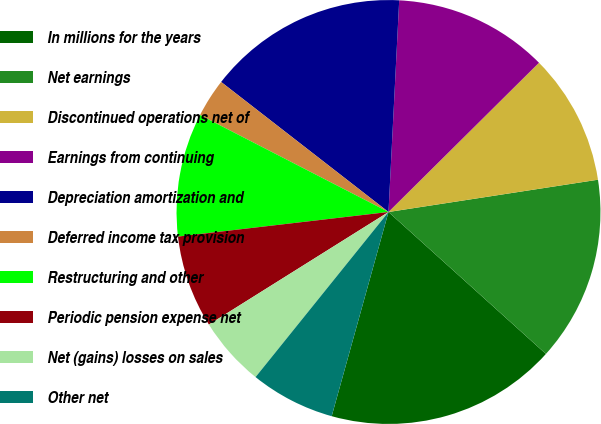Convert chart. <chart><loc_0><loc_0><loc_500><loc_500><pie_chart><fcel>In millions for the years<fcel>Net earnings<fcel>Discontinued operations net of<fcel>Earnings from continuing<fcel>Depreciation amortization and<fcel>Deferred income tax provision<fcel>Restructuring and other<fcel>Periodic pension expense net<fcel>Net (gains) losses on sales<fcel>Other net<nl><fcel>17.64%<fcel>14.11%<fcel>10.0%<fcel>11.76%<fcel>15.29%<fcel>2.95%<fcel>9.41%<fcel>7.06%<fcel>5.3%<fcel>6.47%<nl></chart> 